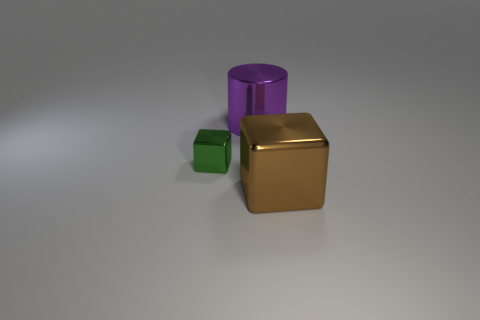How many things are either large brown cubes or big purple cylinders?
Offer a terse response. 2. There is a purple cylinder; is it the same size as the cube that is in front of the tiny green metal block?
Provide a succinct answer. Yes. There is a metallic cube that is right of the big purple thing behind the block right of the small metallic block; how big is it?
Your response must be concise. Large. Is there a brown shiny cube?
Keep it short and to the point. Yes. What number of other tiny objects have the same color as the tiny metal object?
Give a very brief answer. 0. What number of things are big cubes on the right side of the large purple thing or large things behind the large brown block?
Offer a terse response. 2. There is a cube that is on the right side of the purple metal cylinder; how many large things are on the right side of it?
Offer a terse response. 0. There is a cylinder that is the same material as the big brown block; what is its color?
Offer a terse response. Purple. Is there another metal cube that has the same size as the green cube?
Your response must be concise. No. The brown metal thing that is the same size as the purple shiny thing is what shape?
Your answer should be very brief. Cube. 